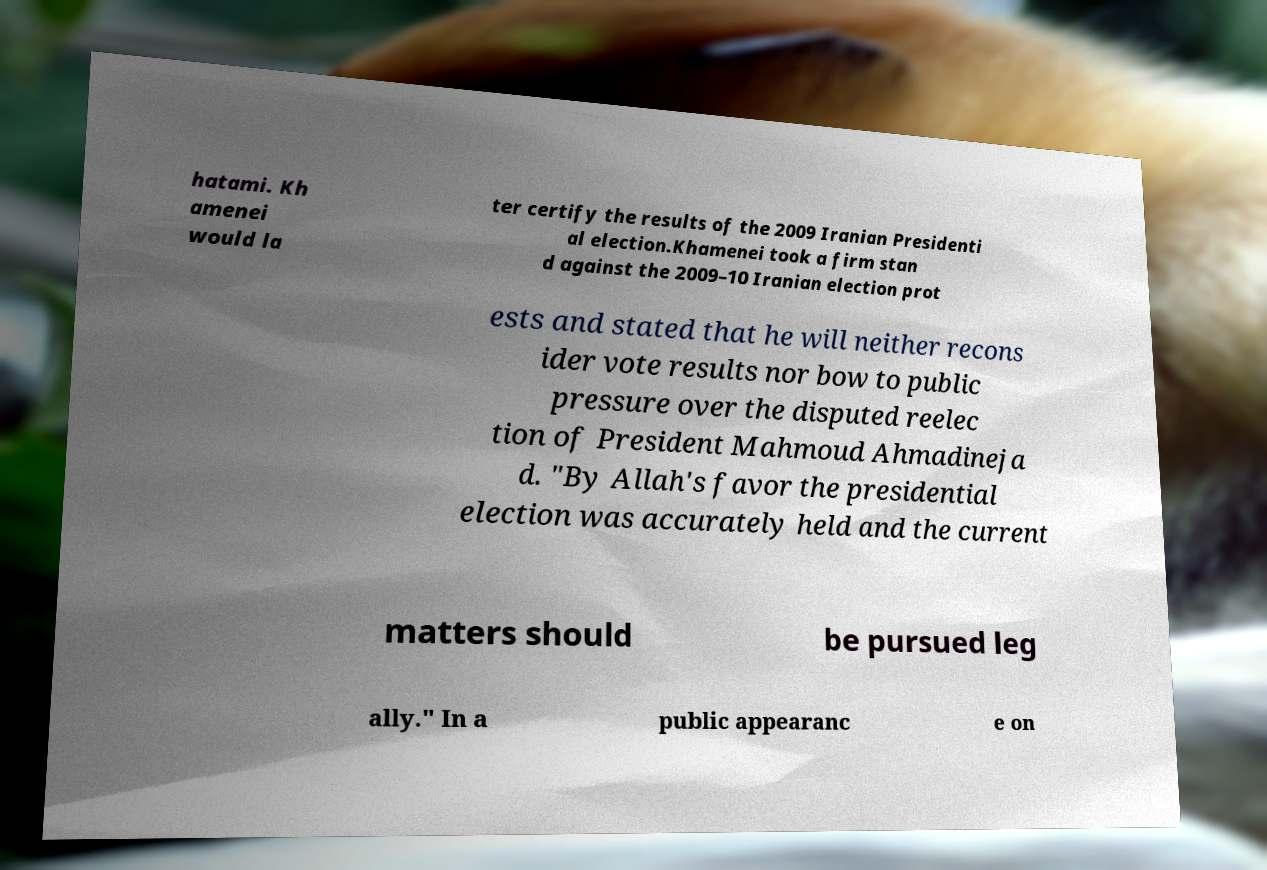There's text embedded in this image that I need extracted. Can you transcribe it verbatim? hatami. Kh amenei would la ter certify the results of the 2009 Iranian Presidenti al election.Khamenei took a firm stan d against the 2009–10 Iranian election prot ests and stated that he will neither recons ider vote results nor bow to public pressure over the disputed reelec tion of President Mahmoud Ahmadineja d. "By Allah's favor the presidential election was accurately held and the current matters should be pursued leg ally." In a public appearanc e on 